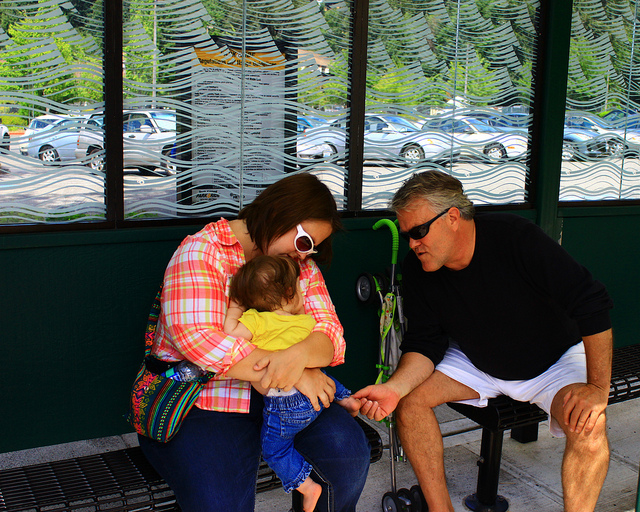<image>Is that a baby girl? I am not sure if that is a baby girl. However, most answers imply that it could be a girl. Is that a baby girl? It is not clear if that is a baby girl. It can be both a baby girl or not. 